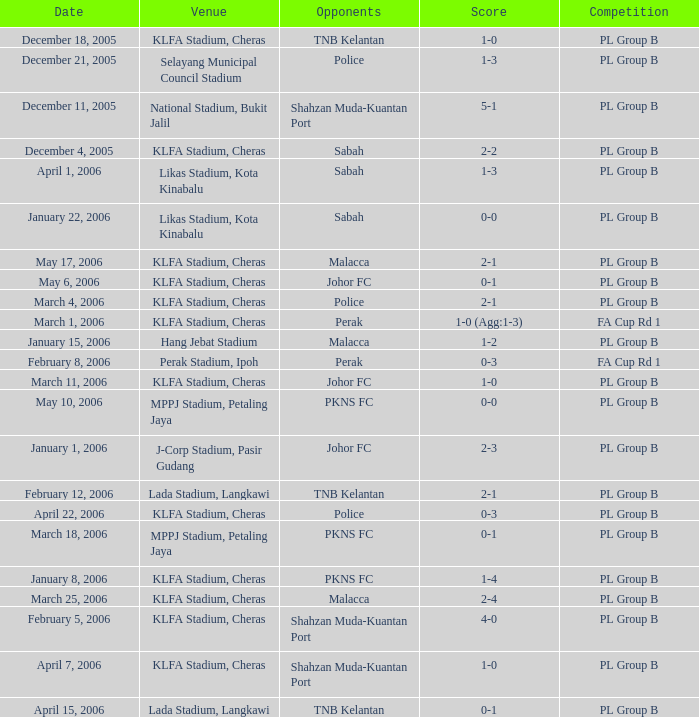At which location is the pl group b competition with a 2-2 score happening? KLFA Stadium, Cheras. 